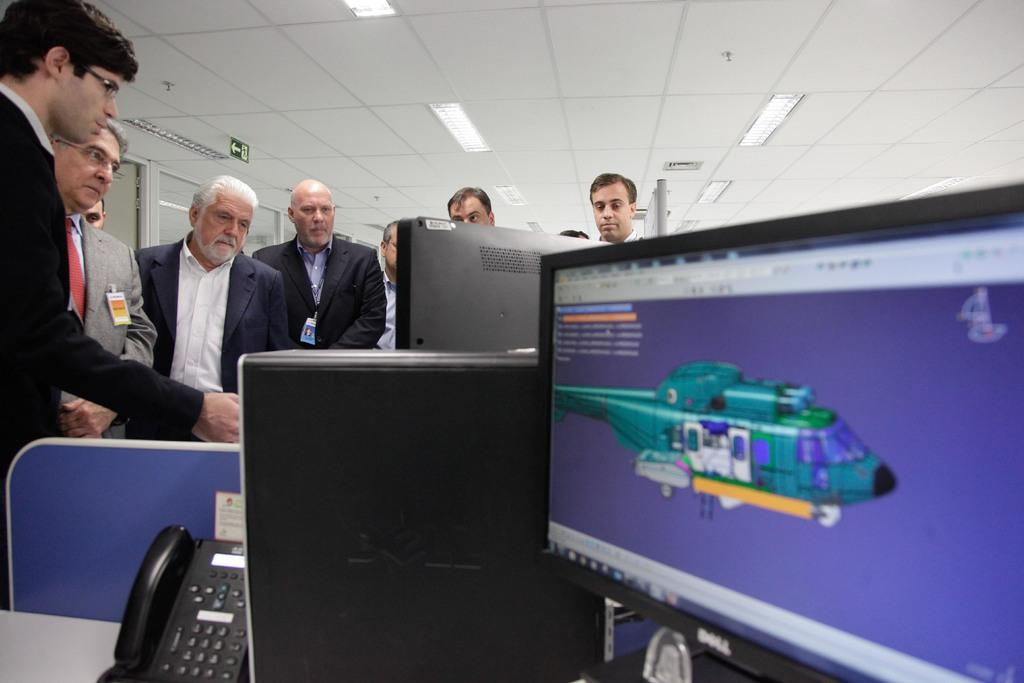What type of electronic devices are present in the image? There are monitors and a CPU in the image. What other object can be seen in the image? There is a telephone in the image. Can you describe the people in the image? There is a group of people standing behind the monitors. What type of lighting is visible in the image? There are ceiling lights visible in the image. What additional feature is present in the image? There is a sign board in the image. How many basketballs are being used by the people in the image? There are no basketballs present in the image. What type of creature is the scarecrow interacting with in the image? There is no scarecrow or creature present in the image. 